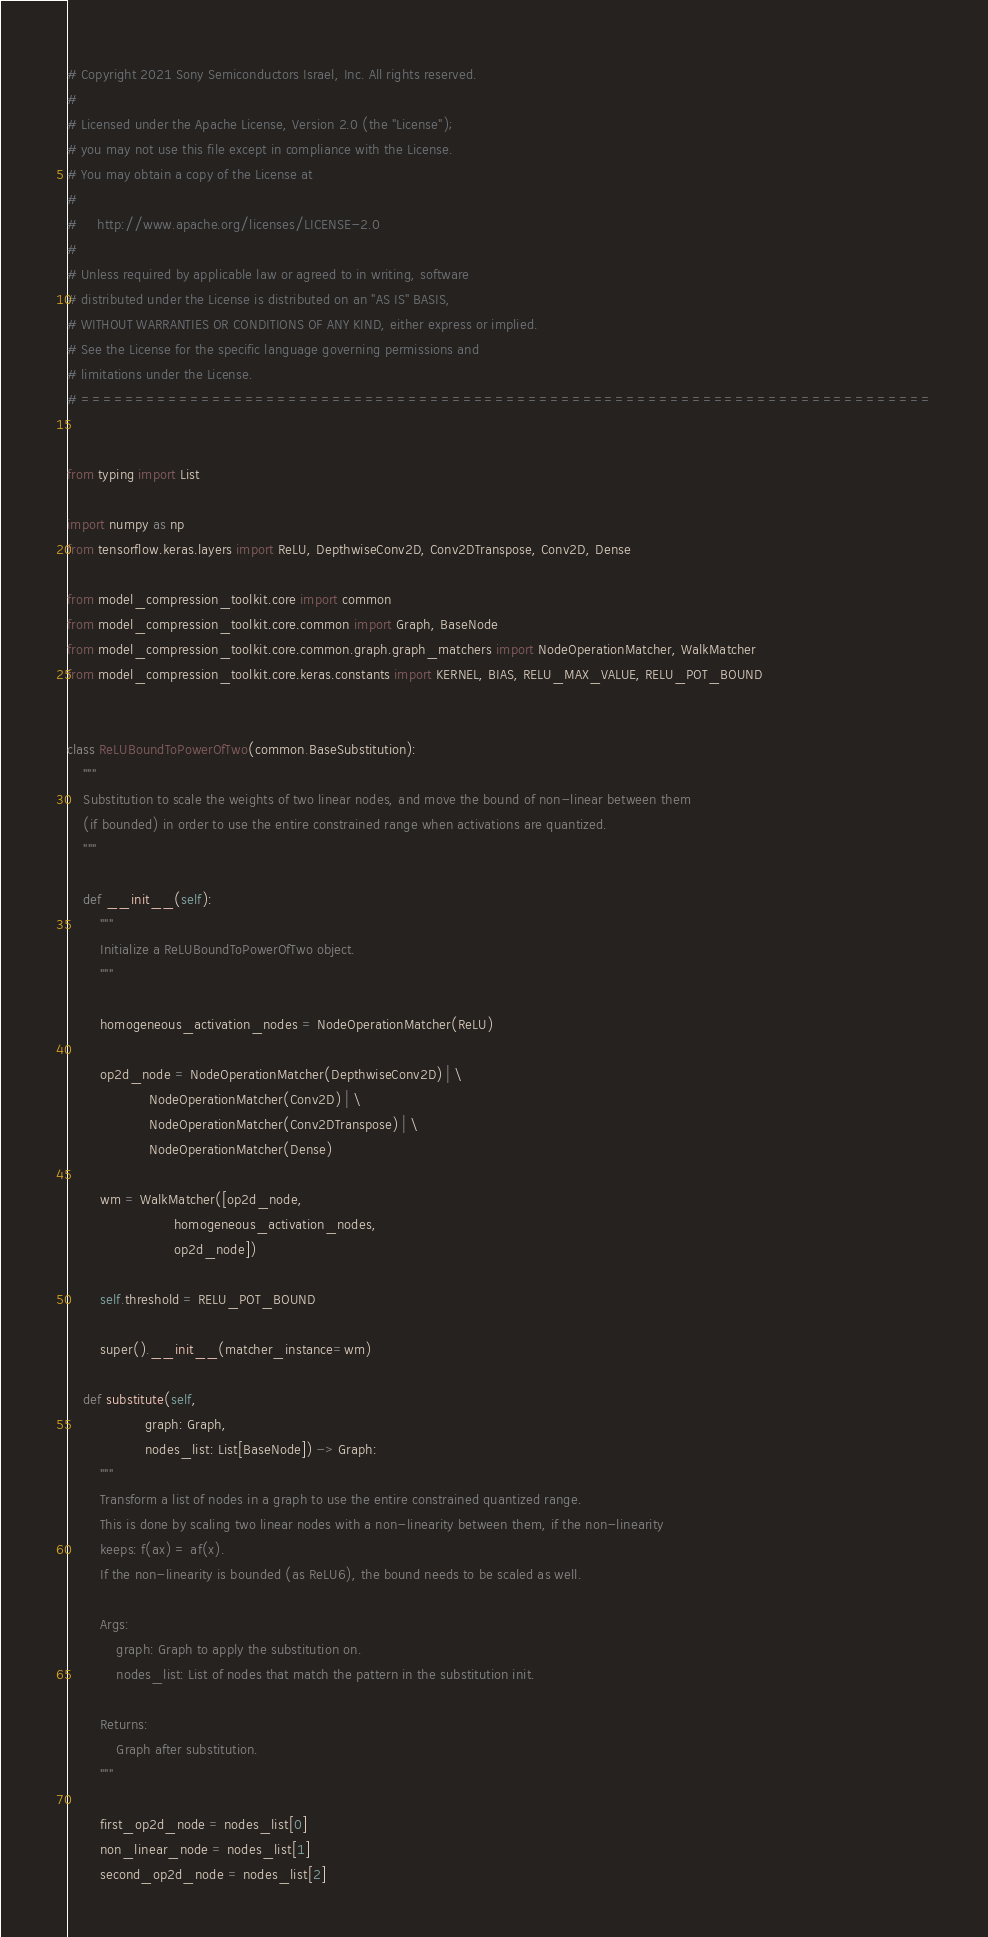Convert code to text. <code><loc_0><loc_0><loc_500><loc_500><_Python_># Copyright 2021 Sony Semiconductors Israel, Inc. All rights reserved.
#
# Licensed under the Apache License, Version 2.0 (the "License");
# you may not use this file except in compliance with the License.
# You may obtain a copy of the License at
#
#     http://www.apache.org/licenses/LICENSE-2.0
#
# Unless required by applicable law or agreed to in writing, software
# distributed under the License is distributed on an "AS IS" BASIS,
# WITHOUT WARRANTIES OR CONDITIONS OF ANY KIND, either express or implied.
# See the License for the specific language governing permissions and
# limitations under the License.
# ==============================================================================


from typing import List

import numpy as np
from tensorflow.keras.layers import ReLU, DepthwiseConv2D, Conv2DTranspose, Conv2D, Dense

from model_compression_toolkit.core import common
from model_compression_toolkit.core.common import Graph, BaseNode
from model_compression_toolkit.core.common.graph.graph_matchers import NodeOperationMatcher, WalkMatcher
from model_compression_toolkit.core.keras.constants import KERNEL, BIAS, RELU_MAX_VALUE, RELU_POT_BOUND


class ReLUBoundToPowerOfTwo(common.BaseSubstitution):
    """
    Substitution to scale the weights of two linear nodes, and move the bound of non-linear between them
    (if bounded) in order to use the entire constrained range when activations are quantized.
    """

    def __init__(self):
        """
        Initialize a ReLUBoundToPowerOfTwo object.
        """

        homogeneous_activation_nodes = NodeOperationMatcher(ReLU)

        op2d_node = NodeOperationMatcher(DepthwiseConv2D) | \
                    NodeOperationMatcher(Conv2D) | \
                    NodeOperationMatcher(Conv2DTranspose) | \
                    NodeOperationMatcher(Dense)

        wm = WalkMatcher([op2d_node,
                          homogeneous_activation_nodes,
                          op2d_node])

        self.threshold = RELU_POT_BOUND

        super().__init__(matcher_instance=wm)

    def substitute(self,
                   graph: Graph,
                   nodes_list: List[BaseNode]) -> Graph:
        """
        Transform a list of nodes in a graph to use the entire constrained quantized range.
        This is done by scaling two linear nodes with a non-linearity between them, if the non-linearity
        keeps: f(ax) = af(x).
        If the non-linearity is bounded (as ReLU6), the bound needs to be scaled as well.

        Args:
            graph: Graph to apply the substitution on.
            nodes_list: List of nodes that match the pattern in the substitution init.

        Returns:
            Graph after substitution.
        """

        first_op2d_node = nodes_list[0]
        non_linear_node = nodes_list[1]
        second_op2d_node = nodes_list[2]
</code> 